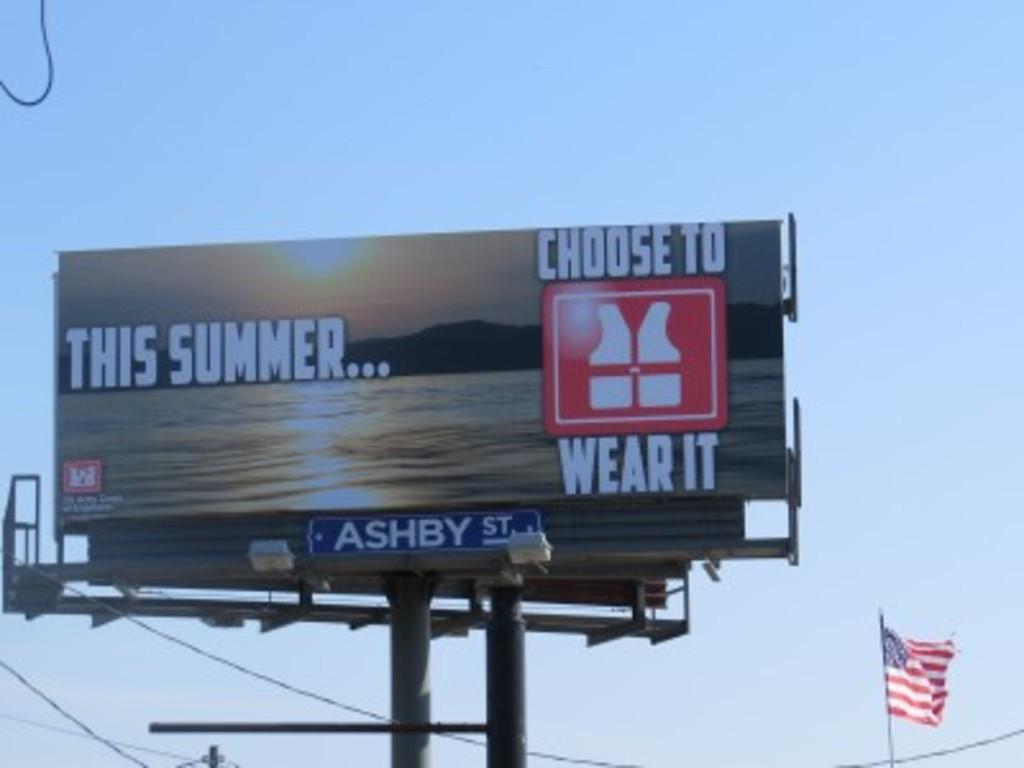What is being advertised?
Make the answer very short. Lifevest. Is summer or winter mentioned?
Your answer should be compact. Summer. 